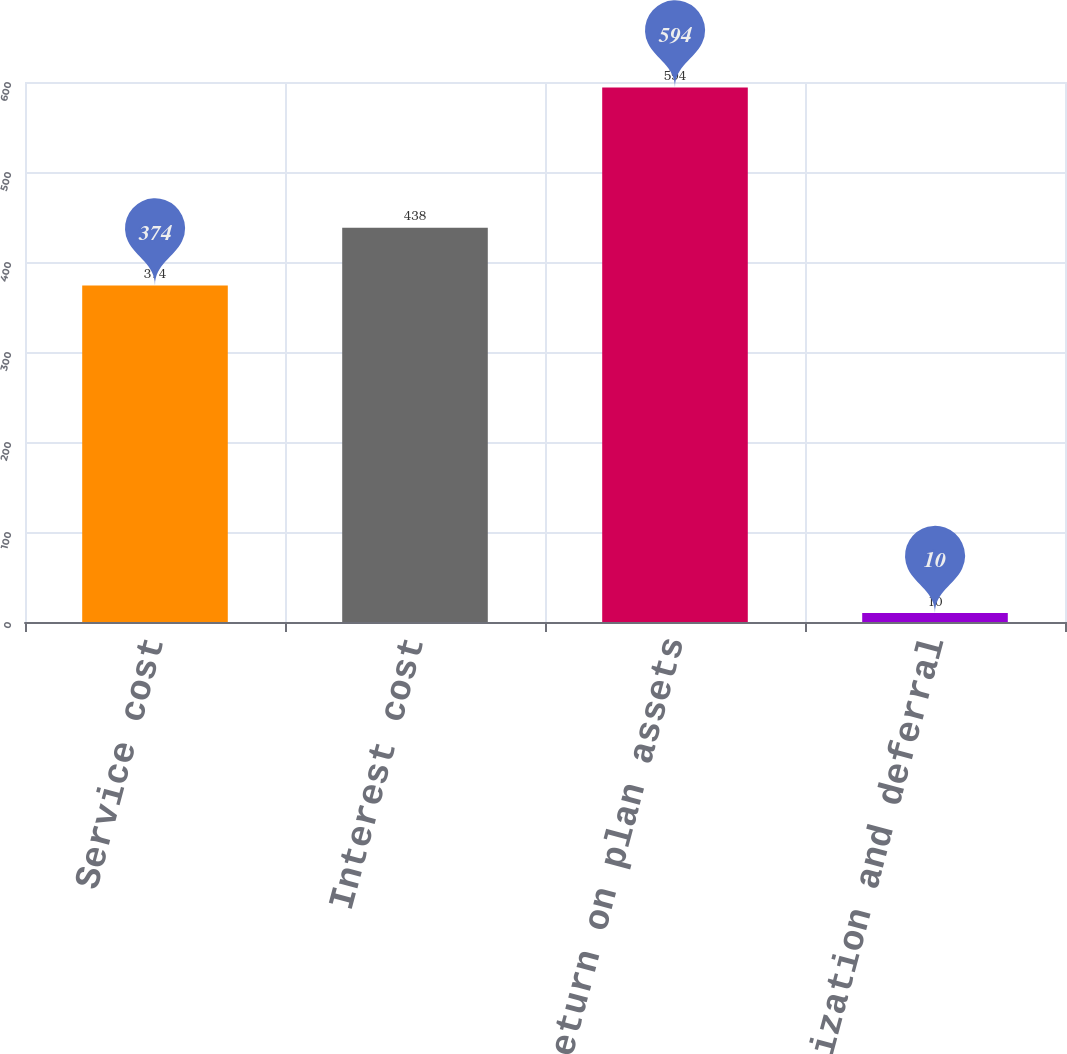Convert chart. <chart><loc_0><loc_0><loc_500><loc_500><bar_chart><fcel>Service cost<fcel>Interest cost<fcel>Expected return on plan assets<fcel>Net amortization and deferral<nl><fcel>374<fcel>438<fcel>594<fcel>10<nl></chart> 